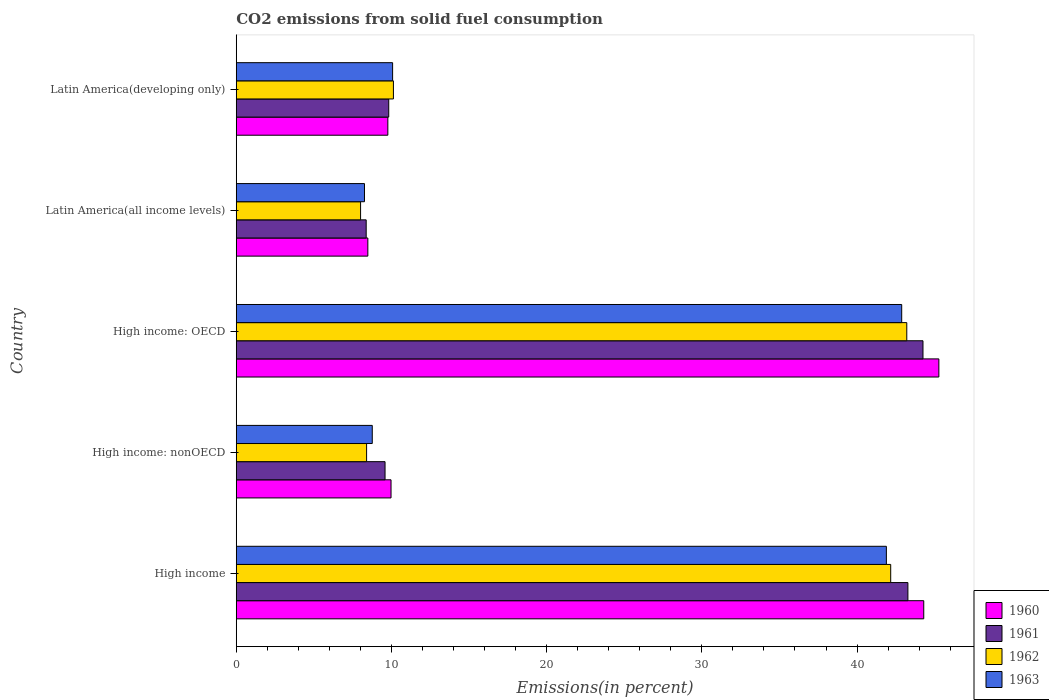How many groups of bars are there?
Give a very brief answer. 5. Are the number of bars on each tick of the Y-axis equal?
Offer a very short reply. Yes. How many bars are there on the 5th tick from the top?
Ensure brevity in your answer.  4. What is the label of the 5th group of bars from the top?
Make the answer very short. High income. What is the total CO2 emitted in 1961 in High income: OECD?
Provide a short and direct response. 44.25. Across all countries, what is the maximum total CO2 emitted in 1961?
Keep it short and to the point. 44.25. Across all countries, what is the minimum total CO2 emitted in 1960?
Offer a very short reply. 8.48. In which country was the total CO2 emitted in 1963 maximum?
Provide a short and direct response. High income: OECD. In which country was the total CO2 emitted in 1961 minimum?
Keep it short and to the point. Latin America(all income levels). What is the total total CO2 emitted in 1961 in the graph?
Make the answer very short. 115.31. What is the difference between the total CO2 emitted in 1962 in High income: nonOECD and that in Latin America(all income levels)?
Your answer should be very brief. 0.39. What is the difference between the total CO2 emitted in 1960 in High income and the total CO2 emitted in 1963 in High income: OECD?
Keep it short and to the point. 1.42. What is the average total CO2 emitted in 1963 per country?
Your answer should be very brief. 22.37. What is the difference between the total CO2 emitted in 1961 and total CO2 emitted in 1963 in High income: OECD?
Give a very brief answer. 1.37. What is the ratio of the total CO2 emitted in 1961 in Latin America(all income levels) to that in Latin America(developing only)?
Make the answer very short. 0.85. Is the total CO2 emitted in 1960 in High income: nonOECD less than that in Latin America(all income levels)?
Give a very brief answer. No. What is the difference between the highest and the second highest total CO2 emitted in 1963?
Keep it short and to the point. 0.99. What is the difference between the highest and the lowest total CO2 emitted in 1963?
Your response must be concise. 34.61. In how many countries, is the total CO2 emitted in 1962 greater than the average total CO2 emitted in 1962 taken over all countries?
Provide a succinct answer. 2. Is the sum of the total CO2 emitted in 1962 in High income and High income: OECD greater than the maximum total CO2 emitted in 1960 across all countries?
Provide a succinct answer. Yes. Is it the case that in every country, the sum of the total CO2 emitted in 1963 and total CO2 emitted in 1960 is greater than the sum of total CO2 emitted in 1962 and total CO2 emitted in 1961?
Offer a terse response. No. What does the 4th bar from the top in High income: nonOECD represents?
Offer a terse response. 1960. Is it the case that in every country, the sum of the total CO2 emitted in 1961 and total CO2 emitted in 1963 is greater than the total CO2 emitted in 1960?
Your response must be concise. Yes. How many bars are there?
Your answer should be very brief. 20. Are the values on the major ticks of X-axis written in scientific E-notation?
Give a very brief answer. No. Does the graph contain any zero values?
Offer a very short reply. No. How many legend labels are there?
Make the answer very short. 4. What is the title of the graph?
Provide a succinct answer. CO2 emissions from solid fuel consumption. Does "1972" appear as one of the legend labels in the graph?
Provide a succinct answer. No. What is the label or title of the X-axis?
Provide a short and direct response. Emissions(in percent). What is the Emissions(in percent) of 1960 in High income?
Make the answer very short. 44.3. What is the Emissions(in percent) of 1961 in High income?
Keep it short and to the point. 43.28. What is the Emissions(in percent) of 1962 in High income?
Your response must be concise. 42.17. What is the Emissions(in percent) of 1963 in High income?
Your answer should be very brief. 41.89. What is the Emissions(in percent) of 1960 in High income: nonOECD?
Your response must be concise. 9.97. What is the Emissions(in percent) of 1961 in High income: nonOECD?
Ensure brevity in your answer.  9.59. What is the Emissions(in percent) in 1962 in High income: nonOECD?
Your answer should be very brief. 8.4. What is the Emissions(in percent) of 1963 in High income: nonOECD?
Offer a terse response. 8.76. What is the Emissions(in percent) of 1960 in High income: OECD?
Make the answer very short. 45.27. What is the Emissions(in percent) in 1961 in High income: OECD?
Provide a short and direct response. 44.25. What is the Emissions(in percent) in 1962 in High income: OECD?
Provide a short and direct response. 43.2. What is the Emissions(in percent) of 1963 in High income: OECD?
Give a very brief answer. 42.88. What is the Emissions(in percent) in 1960 in Latin America(all income levels)?
Offer a terse response. 8.48. What is the Emissions(in percent) in 1961 in Latin America(all income levels)?
Give a very brief answer. 8.37. What is the Emissions(in percent) of 1962 in Latin America(all income levels)?
Provide a short and direct response. 8.01. What is the Emissions(in percent) of 1963 in Latin America(all income levels)?
Your response must be concise. 8.26. What is the Emissions(in percent) in 1960 in Latin America(developing only)?
Keep it short and to the point. 9.77. What is the Emissions(in percent) in 1961 in Latin America(developing only)?
Keep it short and to the point. 9.82. What is the Emissions(in percent) of 1962 in Latin America(developing only)?
Make the answer very short. 10.13. What is the Emissions(in percent) in 1963 in Latin America(developing only)?
Offer a very short reply. 10.07. Across all countries, what is the maximum Emissions(in percent) in 1960?
Ensure brevity in your answer.  45.27. Across all countries, what is the maximum Emissions(in percent) of 1961?
Your answer should be compact. 44.25. Across all countries, what is the maximum Emissions(in percent) in 1962?
Your answer should be compact. 43.2. Across all countries, what is the maximum Emissions(in percent) of 1963?
Your answer should be compact. 42.88. Across all countries, what is the minimum Emissions(in percent) of 1960?
Offer a terse response. 8.48. Across all countries, what is the minimum Emissions(in percent) of 1961?
Provide a short and direct response. 8.37. Across all countries, what is the minimum Emissions(in percent) of 1962?
Ensure brevity in your answer.  8.01. Across all countries, what is the minimum Emissions(in percent) in 1963?
Make the answer very short. 8.26. What is the total Emissions(in percent) in 1960 in the graph?
Provide a short and direct response. 117.78. What is the total Emissions(in percent) in 1961 in the graph?
Provide a succinct answer. 115.31. What is the total Emissions(in percent) of 1962 in the graph?
Offer a terse response. 111.91. What is the total Emissions(in percent) of 1963 in the graph?
Give a very brief answer. 111.86. What is the difference between the Emissions(in percent) of 1960 in High income and that in High income: nonOECD?
Provide a short and direct response. 34.32. What is the difference between the Emissions(in percent) in 1961 in High income and that in High income: nonOECD?
Offer a very short reply. 33.69. What is the difference between the Emissions(in percent) of 1962 in High income and that in High income: nonOECD?
Offer a terse response. 33.77. What is the difference between the Emissions(in percent) of 1963 in High income and that in High income: nonOECD?
Your response must be concise. 33.12. What is the difference between the Emissions(in percent) of 1960 in High income and that in High income: OECD?
Provide a short and direct response. -0.97. What is the difference between the Emissions(in percent) in 1961 in High income and that in High income: OECD?
Your answer should be compact. -0.97. What is the difference between the Emissions(in percent) of 1962 in High income and that in High income: OECD?
Keep it short and to the point. -1.04. What is the difference between the Emissions(in percent) of 1963 in High income and that in High income: OECD?
Give a very brief answer. -0.99. What is the difference between the Emissions(in percent) in 1960 in High income and that in Latin America(all income levels)?
Your answer should be compact. 35.82. What is the difference between the Emissions(in percent) in 1961 in High income and that in Latin America(all income levels)?
Ensure brevity in your answer.  34.9. What is the difference between the Emissions(in percent) of 1962 in High income and that in Latin America(all income levels)?
Your response must be concise. 34.16. What is the difference between the Emissions(in percent) of 1963 in High income and that in Latin America(all income levels)?
Your answer should be compact. 33.63. What is the difference between the Emissions(in percent) of 1960 in High income and that in Latin America(developing only)?
Offer a terse response. 34.53. What is the difference between the Emissions(in percent) in 1961 in High income and that in Latin America(developing only)?
Make the answer very short. 33.45. What is the difference between the Emissions(in percent) in 1962 in High income and that in Latin America(developing only)?
Your response must be concise. 32.04. What is the difference between the Emissions(in percent) of 1963 in High income and that in Latin America(developing only)?
Keep it short and to the point. 31.81. What is the difference between the Emissions(in percent) of 1960 in High income: nonOECD and that in High income: OECD?
Give a very brief answer. -35.3. What is the difference between the Emissions(in percent) in 1961 in High income: nonOECD and that in High income: OECD?
Your response must be concise. -34.66. What is the difference between the Emissions(in percent) in 1962 in High income: nonOECD and that in High income: OECD?
Ensure brevity in your answer.  -34.81. What is the difference between the Emissions(in percent) of 1963 in High income: nonOECD and that in High income: OECD?
Give a very brief answer. -34.11. What is the difference between the Emissions(in percent) of 1960 in High income: nonOECD and that in Latin America(all income levels)?
Your answer should be very brief. 1.49. What is the difference between the Emissions(in percent) of 1961 in High income: nonOECD and that in Latin America(all income levels)?
Give a very brief answer. 1.22. What is the difference between the Emissions(in percent) of 1962 in High income: nonOECD and that in Latin America(all income levels)?
Your response must be concise. 0.39. What is the difference between the Emissions(in percent) of 1963 in High income: nonOECD and that in Latin America(all income levels)?
Offer a terse response. 0.5. What is the difference between the Emissions(in percent) of 1960 in High income: nonOECD and that in Latin America(developing only)?
Ensure brevity in your answer.  0.21. What is the difference between the Emissions(in percent) of 1961 in High income: nonOECD and that in Latin America(developing only)?
Ensure brevity in your answer.  -0.24. What is the difference between the Emissions(in percent) of 1962 in High income: nonOECD and that in Latin America(developing only)?
Give a very brief answer. -1.73. What is the difference between the Emissions(in percent) in 1963 in High income: nonOECD and that in Latin America(developing only)?
Provide a short and direct response. -1.31. What is the difference between the Emissions(in percent) in 1960 in High income: OECD and that in Latin America(all income levels)?
Provide a succinct answer. 36.79. What is the difference between the Emissions(in percent) of 1961 in High income: OECD and that in Latin America(all income levels)?
Give a very brief answer. 35.88. What is the difference between the Emissions(in percent) in 1962 in High income: OECD and that in Latin America(all income levels)?
Make the answer very short. 35.19. What is the difference between the Emissions(in percent) of 1963 in High income: OECD and that in Latin America(all income levels)?
Offer a very short reply. 34.61. What is the difference between the Emissions(in percent) of 1960 in High income: OECD and that in Latin America(developing only)?
Your answer should be very brief. 35.5. What is the difference between the Emissions(in percent) of 1961 in High income: OECD and that in Latin America(developing only)?
Your response must be concise. 34.42. What is the difference between the Emissions(in percent) of 1962 in High income: OECD and that in Latin America(developing only)?
Make the answer very short. 33.08. What is the difference between the Emissions(in percent) in 1963 in High income: OECD and that in Latin America(developing only)?
Your response must be concise. 32.8. What is the difference between the Emissions(in percent) in 1960 in Latin America(all income levels) and that in Latin America(developing only)?
Your answer should be compact. -1.29. What is the difference between the Emissions(in percent) of 1961 in Latin America(all income levels) and that in Latin America(developing only)?
Make the answer very short. -1.45. What is the difference between the Emissions(in percent) in 1962 in Latin America(all income levels) and that in Latin America(developing only)?
Provide a short and direct response. -2.12. What is the difference between the Emissions(in percent) in 1963 in Latin America(all income levels) and that in Latin America(developing only)?
Your answer should be compact. -1.81. What is the difference between the Emissions(in percent) of 1960 in High income and the Emissions(in percent) of 1961 in High income: nonOECD?
Your answer should be very brief. 34.71. What is the difference between the Emissions(in percent) of 1960 in High income and the Emissions(in percent) of 1962 in High income: nonOECD?
Your answer should be compact. 35.9. What is the difference between the Emissions(in percent) in 1960 in High income and the Emissions(in percent) in 1963 in High income: nonOECD?
Ensure brevity in your answer.  35.53. What is the difference between the Emissions(in percent) in 1961 in High income and the Emissions(in percent) in 1962 in High income: nonOECD?
Keep it short and to the point. 34.88. What is the difference between the Emissions(in percent) of 1961 in High income and the Emissions(in percent) of 1963 in High income: nonOECD?
Offer a terse response. 34.51. What is the difference between the Emissions(in percent) in 1962 in High income and the Emissions(in percent) in 1963 in High income: nonOECD?
Provide a short and direct response. 33.4. What is the difference between the Emissions(in percent) in 1960 in High income and the Emissions(in percent) in 1961 in High income: OECD?
Make the answer very short. 0.05. What is the difference between the Emissions(in percent) of 1960 in High income and the Emissions(in percent) of 1962 in High income: OECD?
Your response must be concise. 1.09. What is the difference between the Emissions(in percent) in 1960 in High income and the Emissions(in percent) in 1963 in High income: OECD?
Keep it short and to the point. 1.42. What is the difference between the Emissions(in percent) of 1961 in High income and the Emissions(in percent) of 1962 in High income: OECD?
Your answer should be compact. 0.07. What is the difference between the Emissions(in percent) in 1961 in High income and the Emissions(in percent) in 1963 in High income: OECD?
Ensure brevity in your answer.  0.4. What is the difference between the Emissions(in percent) of 1962 in High income and the Emissions(in percent) of 1963 in High income: OECD?
Provide a short and direct response. -0.71. What is the difference between the Emissions(in percent) in 1960 in High income and the Emissions(in percent) in 1961 in Latin America(all income levels)?
Ensure brevity in your answer.  35.92. What is the difference between the Emissions(in percent) in 1960 in High income and the Emissions(in percent) in 1962 in Latin America(all income levels)?
Your answer should be very brief. 36.29. What is the difference between the Emissions(in percent) of 1960 in High income and the Emissions(in percent) of 1963 in Latin America(all income levels)?
Provide a succinct answer. 36.03. What is the difference between the Emissions(in percent) in 1961 in High income and the Emissions(in percent) in 1962 in Latin America(all income levels)?
Your answer should be compact. 35.27. What is the difference between the Emissions(in percent) in 1961 in High income and the Emissions(in percent) in 1963 in Latin America(all income levels)?
Ensure brevity in your answer.  35.01. What is the difference between the Emissions(in percent) of 1962 in High income and the Emissions(in percent) of 1963 in Latin America(all income levels)?
Provide a succinct answer. 33.91. What is the difference between the Emissions(in percent) in 1960 in High income and the Emissions(in percent) in 1961 in Latin America(developing only)?
Provide a succinct answer. 34.47. What is the difference between the Emissions(in percent) in 1960 in High income and the Emissions(in percent) in 1962 in Latin America(developing only)?
Provide a succinct answer. 34.17. What is the difference between the Emissions(in percent) in 1960 in High income and the Emissions(in percent) in 1963 in Latin America(developing only)?
Give a very brief answer. 34.22. What is the difference between the Emissions(in percent) of 1961 in High income and the Emissions(in percent) of 1962 in Latin America(developing only)?
Offer a very short reply. 33.15. What is the difference between the Emissions(in percent) in 1961 in High income and the Emissions(in percent) in 1963 in Latin America(developing only)?
Your answer should be very brief. 33.2. What is the difference between the Emissions(in percent) in 1962 in High income and the Emissions(in percent) in 1963 in Latin America(developing only)?
Provide a short and direct response. 32.09. What is the difference between the Emissions(in percent) in 1960 in High income: nonOECD and the Emissions(in percent) in 1961 in High income: OECD?
Offer a terse response. -34.27. What is the difference between the Emissions(in percent) of 1960 in High income: nonOECD and the Emissions(in percent) of 1962 in High income: OECD?
Provide a succinct answer. -33.23. What is the difference between the Emissions(in percent) in 1960 in High income: nonOECD and the Emissions(in percent) in 1963 in High income: OECD?
Provide a short and direct response. -32.9. What is the difference between the Emissions(in percent) of 1961 in High income: nonOECD and the Emissions(in percent) of 1962 in High income: OECD?
Keep it short and to the point. -33.62. What is the difference between the Emissions(in percent) of 1961 in High income: nonOECD and the Emissions(in percent) of 1963 in High income: OECD?
Ensure brevity in your answer.  -33.29. What is the difference between the Emissions(in percent) in 1962 in High income: nonOECD and the Emissions(in percent) in 1963 in High income: OECD?
Offer a terse response. -34.48. What is the difference between the Emissions(in percent) of 1960 in High income: nonOECD and the Emissions(in percent) of 1961 in Latin America(all income levels)?
Your answer should be compact. 1.6. What is the difference between the Emissions(in percent) of 1960 in High income: nonOECD and the Emissions(in percent) of 1962 in Latin America(all income levels)?
Provide a succinct answer. 1.96. What is the difference between the Emissions(in percent) of 1960 in High income: nonOECD and the Emissions(in percent) of 1963 in Latin America(all income levels)?
Offer a terse response. 1.71. What is the difference between the Emissions(in percent) of 1961 in High income: nonOECD and the Emissions(in percent) of 1962 in Latin America(all income levels)?
Give a very brief answer. 1.58. What is the difference between the Emissions(in percent) in 1961 in High income: nonOECD and the Emissions(in percent) in 1963 in Latin America(all income levels)?
Ensure brevity in your answer.  1.32. What is the difference between the Emissions(in percent) in 1962 in High income: nonOECD and the Emissions(in percent) in 1963 in Latin America(all income levels)?
Your answer should be very brief. 0.14. What is the difference between the Emissions(in percent) in 1960 in High income: nonOECD and the Emissions(in percent) in 1961 in Latin America(developing only)?
Your response must be concise. 0.15. What is the difference between the Emissions(in percent) of 1960 in High income: nonOECD and the Emissions(in percent) of 1962 in Latin America(developing only)?
Your answer should be compact. -0.15. What is the difference between the Emissions(in percent) in 1960 in High income: nonOECD and the Emissions(in percent) in 1963 in Latin America(developing only)?
Give a very brief answer. -0.1. What is the difference between the Emissions(in percent) in 1961 in High income: nonOECD and the Emissions(in percent) in 1962 in Latin America(developing only)?
Provide a succinct answer. -0.54. What is the difference between the Emissions(in percent) of 1961 in High income: nonOECD and the Emissions(in percent) of 1963 in Latin America(developing only)?
Make the answer very short. -0.49. What is the difference between the Emissions(in percent) in 1962 in High income: nonOECD and the Emissions(in percent) in 1963 in Latin America(developing only)?
Your answer should be very brief. -1.68. What is the difference between the Emissions(in percent) of 1960 in High income: OECD and the Emissions(in percent) of 1961 in Latin America(all income levels)?
Offer a very short reply. 36.9. What is the difference between the Emissions(in percent) of 1960 in High income: OECD and the Emissions(in percent) of 1962 in Latin America(all income levels)?
Keep it short and to the point. 37.26. What is the difference between the Emissions(in percent) in 1960 in High income: OECD and the Emissions(in percent) in 1963 in Latin America(all income levels)?
Keep it short and to the point. 37.01. What is the difference between the Emissions(in percent) of 1961 in High income: OECD and the Emissions(in percent) of 1962 in Latin America(all income levels)?
Provide a short and direct response. 36.24. What is the difference between the Emissions(in percent) in 1961 in High income: OECD and the Emissions(in percent) in 1963 in Latin America(all income levels)?
Offer a terse response. 35.99. What is the difference between the Emissions(in percent) of 1962 in High income: OECD and the Emissions(in percent) of 1963 in Latin America(all income levels)?
Provide a short and direct response. 34.94. What is the difference between the Emissions(in percent) in 1960 in High income: OECD and the Emissions(in percent) in 1961 in Latin America(developing only)?
Your answer should be compact. 35.45. What is the difference between the Emissions(in percent) in 1960 in High income: OECD and the Emissions(in percent) in 1962 in Latin America(developing only)?
Your response must be concise. 35.14. What is the difference between the Emissions(in percent) in 1960 in High income: OECD and the Emissions(in percent) in 1963 in Latin America(developing only)?
Provide a succinct answer. 35.2. What is the difference between the Emissions(in percent) in 1961 in High income: OECD and the Emissions(in percent) in 1962 in Latin America(developing only)?
Offer a very short reply. 34.12. What is the difference between the Emissions(in percent) of 1961 in High income: OECD and the Emissions(in percent) of 1963 in Latin America(developing only)?
Provide a short and direct response. 34.17. What is the difference between the Emissions(in percent) in 1962 in High income: OECD and the Emissions(in percent) in 1963 in Latin America(developing only)?
Make the answer very short. 33.13. What is the difference between the Emissions(in percent) in 1960 in Latin America(all income levels) and the Emissions(in percent) in 1961 in Latin America(developing only)?
Keep it short and to the point. -1.35. What is the difference between the Emissions(in percent) in 1960 in Latin America(all income levels) and the Emissions(in percent) in 1962 in Latin America(developing only)?
Offer a very short reply. -1.65. What is the difference between the Emissions(in percent) in 1960 in Latin America(all income levels) and the Emissions(in percent) in 1963 in Latin America(developing only)?
Offer a very short reply. -1.6. What is the difference between the Emissions(in percent) in 1961 in Latin America(all income levels) and the Emissions(in percent) in 1962 in Latin America(developing only)?
Provide a short and direct response. -1.75. What is the difference between the Emissions(in percent) in 1961 in Latin America(all income levels) and the Emissions(in percent) in 1963 in Latin America(developing only)?
Offer a very short reply. -1.7. What is the difference between the Emissions(in percent) in 1962 in Latin America(all income levels) and the Emissions(in percent) in 1963 in Latin America(developing only)?
Provide a succinct answer. -2.06. What is the average Emissions(in percent) in 1960 per country?
Ensure brevity in your answer.  23.56. What is the average Emissions(in percent) in 1961 per country?
Offer a very short reply. 23.06. What is the average Emissions(in percent) of 1962 per country?
Provide a succinct answer. 22.38. What is the average Emissions(in percent) in 1963 per country?
Offer a terse response. 22.37. What is the difference between the Emissions(in percent) in 1960 and Emissions(in percent) in 1961 in High income?
Offer a very short reply. 1.02. What is the difference between the Emissions(in percent) in 1960 and Emissions(in percent) in 1962 in High income?
Your response must be concise. 2.13. What is the difference between the Emissions(in percent) of 1960 and Emissions(in percent) of 1963 in High income?
Your response must be concise. 2.41. What is the difference between the Emissions(in percent) in 1961 and Emissions(in percent) in 1962 in High income?
Offer a very short reply. 1.11. What is the difference between the Emissions(in percent) of 1961 and Emissions(in percent) of 1963 in High income?
Provide a short and direct response. 1.39. What is the difference between the Emissions(in percent) in 1962 and Emissions(in percent) in 1963 in High income?
Your answer should be compact. 0.28. What is the difference between the Emissions(in percent) of 1960 and Emissions(in percent) of 1961 in High income: nonOECD?
Your answer should be very brief. 0.39. What is the difference between the Emissions(in percent) in 1960 and Emissions(in percent) in 1962 in High income: nonOECD?
Offer a very short reply. 1.57. What is the difference between the Emissions(in percent) of 1960 and Emissions(in percent) of 1963 in High income: nonOECD?
Provide a succinct answer. 1.21. What is the difference between the Emissions(in percent) in 1961 and Emissions(in percent) in 1962 in High income: nonOECD?
Offer a very short reply. 1.19. What is the difference between the Emissions(in percent) in 1961 and Emissions(in percent) in 1963 in High income: nonOECD?
Make the answer very short. 0.82. What is the difference between the Emissions(in percent) of 1962 and Emissions(in percent) of 1963 in High income: nonOECD?
Your response must be concise. -0.37. What is the difference between the Emissions(in percent) of 1960 and Emissions(in percent) of 1961 in High income: OECD?
Ensure brevity in your answer.  1.02. What is the difference between the Emissions(in percent) in 1960 and Emissions(in percent) in 1962 in High income: OECD?
Your answer should be very brief. 2.07. What is the difference between the Emissions(in percent) of 1960 and Emissions(in percent) of 1963 in High income: OECD?
Give a very brief answer. 2.39. What is the difference between the Emissions(in percent) of 1961 and Emissions(in percent) of 1962 in High income: OECD?
Make the answer very short. 1.04. What is the difference between the Emissions(in percent) in 1961 and Emissions(in percent) in 1963 in High income: OECD?
Offer a very short reply. 1.37. What is the difference between the Emissions(in percent) of 1962 and Emissions(in percent) of 1963 in High income: OECD?
Offer a terse response. 0.33. What is the difference between the Emissions(in percent) in 1960 and Emissions(in percent) in 1961 in Latin America(all income levels)?
Your response must be concise. 0.11. What is the difference between the Emissions(in percent) in 1960 and Emissions(in percent) in 1962 in Latin America(all income levels)?
Ensure brevity in your answer.  0.47. What is the difference between the Emissions(in percent) in 1960 and Emissions(in percent) in 1963 in Latin America(all income levels)?
Your response must be concise. 0.22. What is the difference between the Emissions(in percent) in 1961 and Emissions(in percent) in 1962 in Latin America(all income levels)?
Provide a succinct answer. 0.36. What is the difference between the Emissions(in percent) of 1961 and Emissions(in percent) of 1963 in Latin America(all income levels)?
Provide a short and direct response. 0.11. What is the difference between the Emissions(in percent) of 1962 and Emissions(in percent) of 1963 in Latin America(all income levels)?
Provide a succinct answer. -0.25. What is the difference between the Emissions(in percent) in 1960 and Emissions(in percent) in 1961 in Latin America(developing only)?
Offer a terse response. -0.06. What is the difference between the Emissions(in percent) of 1960 and Emissions(in percent) of 1962 in Latin America(developing only)?
Keep it short and to the point. -0.36. What is the difference between the Emissions(in percent) in 1960 and Emissions(in percent) in 1963 in Latin America(developing only)?
Make the answer very short. -0.31. What is the difference between the Emissions(in percent) in 1961 and Emissions(in percent) in 1962 in Latin America(developing only)?
Offer a terse response. -0.3. What is the difference between the Emissions(in percent) of 1961 and Emissions(in percent) of 1963 in Latin America(developing only)?
Your response must be concise. -0.25. What is the difference between the Emissions(in percent) in 1962 and Emissions(in percent) in 1963 in Latin America(developing only)?
Ensure brevity in your answer.  0.05. What is the ratio of the Emissions(in percent) in 1960 in High income to that in High income: nonOECD?
Offer a terse response. 4.44. What is the ratio of the Emissions(in percent) of 1961 in High income to that in High income: nonOECD?
Offer a terse response. 4.51. What is the ratio of the Emissions(in percent) in 1962 in High income to that in High income: nonOECD?
Your response must be concise. 5.02. What is the ratio of the Emissions(in percent) in 1963 in High income to that in High income: nonOECD?
Your response must be concise. 4.78. What is the ratio of the Emissions(in percent) of 1960 in High income to that in High income: OECD?
Provide a succinct answer. 0.98. What is the ratio of the Emissions(in percent) of 1960 in High income to that in Latin America(all income levels)?
Your response must be concise. 5.22. What is the ratio of the Emissions(in percent) of 1961 in High income to that in Latin America(all income levels)?
Keep it short and to the point. 5.17. What is the ratio of the Emissions(in percent) of 1962 in High income to that in Latin America(all income levels)?
Provide a succinct answer. 5.26. What is the ratio of the Emissions(in percent) of 1963 in High income to that in Latin America(all income levels)?
Keep it short and to the point. 5.07. What is the ratio of the Emissions(in percent) in 1960 in High income to that in Latin America(developing only)?
Your answer should be compact. 4.54. What is the ratio of the Emissions(in percent) of 1961 in High income to that in Latin America(developing only)?
Provide a succinct answer. 4.4. What is the ratio of the Emissions(in percent) of 1962 in High income to that in Latin America(developing only)?
Provide a succinct answer. 4.16. What is the ratio of the Emissions(in percent) of 1963 in High income to that in Latin America(developing only)?
Make the answer very short. 4.16. What is the ratio of the Emissions(in percent) in 1960 in High income: nonOECD to that in High income: OECD?
Ensure brevity in your answer.  0.22. What is the ratio of the Emissions(in percent) of 1961 in High income: nonOECD to that in High income: OECD?
Your response must be concise. 0.22. What is the ratio of the Emissions(in percent) of 1962 in High income: nonOECD to that in High income: OECD?
Provide a short and direct response. 0.19. What is the ratio of the Emissions(in percent) in 1963 in High income: nonOECD to that in High income: OECD?
Your response must be concise. 0.2. What is the ratio of the Emissions(in percent) of 1960 in High income: nonOECD to that in Latin America(all income levels)?
Make the answer very short. 1.18. What is the ratio of the Emissions(in percent) in 1961 in High income: nonOECD to that in Latin America(all income levels)?
Offer a very short reply. 1.15. What is the ratio of the Emissions(in percent) of 1962 in High income: nonOECD to that in Latin America(all income levels)?
Provide a short and direct response. 1.05. What is the ratio of the Emissions(in percent) of 1963 in High income: nonOECD to that in Latin America(all income levels)?
Keep it short and to the point. 1.06. What is the ratio of the Emissions(in percent) of 1960 in High income: nonOECD to that in Latin America(developing only)?
Your answer should be compact. 1.02. What is the ratio of the Emissions(in percent) of 1961 in High income: nonOECD to that in Latin America(developing only)?
Provide a succinct answer. 0.98. What is the ratio of the Emissions(in percent) of 1962 in High income: nonOECD to that in Latin America(developing only)?
Keep it short and to the point. 0.83. What is the ratio of the Emissions(in percent) in 1963 in High income: nonOECD to that in Latin America(developing only)?
Offer a terse response. 0.87. What is the ratio of the Emissions(in percent) of 1960 in High income: OECD to that in Latin America(all income levels)?
Keep it short and to the point. 5.34. What is the ratio of the Emissions(in percent) in 1961 in High income: OECD to that in Latin America(all income levels)?
Your response must be concise. 5.29. What is the ratio of the Emissions(in percent) in 1962 in High income: OECD to that in Latin America(all income levels)?
Ensure brevity in your answer.  5.39. What is the ratio of the Emissions(in percent) in 1963 in High income: OECD to that in Latin America(all income levels)?
Keep it short and to the point. 5.19. What is the ratio of the Emissions(in percent) in 1960 in High income: OECD to that in Latin America(developing only)?
Your response must be concise. 4.63. What is the ratio of the Emissions(in percent) in 1961 in High income: OECD to that in Latin America(developing only)?
Make the answer very short. 4.5. What is the ratio of the Emissions(in percent) of 1962 in High income: OECD to that in Latin America(developing only)?
Your response must be concise. 4.27. What is the ratio of the Emissions(in percent) of 1963 in High income: OECD to that in Latin America(developing only)?
Provide a succinct answer. 4.26. What is the ratio of the Emissions(in percent) of 1960 in Latin America(all income levels) to that in Latin America(developing only)?
Provide a succinct answer. 0.87. What is the ratio of the Emissions(in percent) of 1961 in Latin America(all income levels) to that in Latin America(developing only)?
Provide a succinct answer. 0.85. What is the ratio of the Emissions(in percent) in 1962 in Latin America(all income levels) to that in Latin America(developing only)?
Ensure brevity in your answer.  0.79. What is the ratio of the Emissions(in percent) in 1963 in Latin America(all income levels) to that in Latin America(developing only)?
Offer a very short reply. 0.82. What is the difference between the highest and the second highest Emissions(in percent) of 1960?
Offer a terse response. 0.97. What is the difference between the highest and the second highest Emissions(in percent) of 1961?
Offer a terse response. 0.97. What is the difference between the highest and the second highest Emissions(in percent) of 1962?
Offer a terse response. 1.04. What is the difference between the highest and the lowest Emissions(in percent) in 1960?
Ensure brevity in your answer.  36.79. What is the difference between the highest and the lowest Emissions(in percent) of 1961?
Keep it short and to the point. 35.88. What is the difference between the highest and the lowest Emissions(in percent) in 1962?
Your answer should be very brief. 35.19. What is the difference between the highest and the lowest Emissions(in percent) of 1963?
Keep it short and to the point. 34.61. 